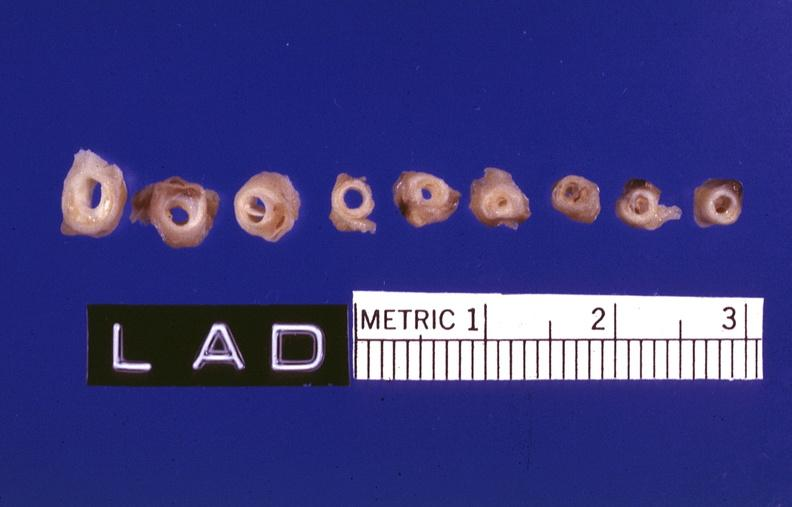what is present?
Answer the question using a single word or phrase. Vasculature 